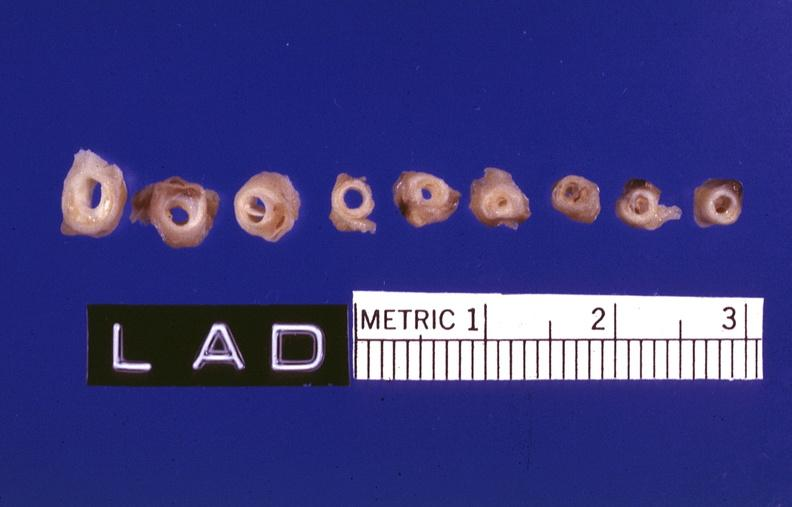what is present?
Answer the question using a single word or phrase. Vasculature 